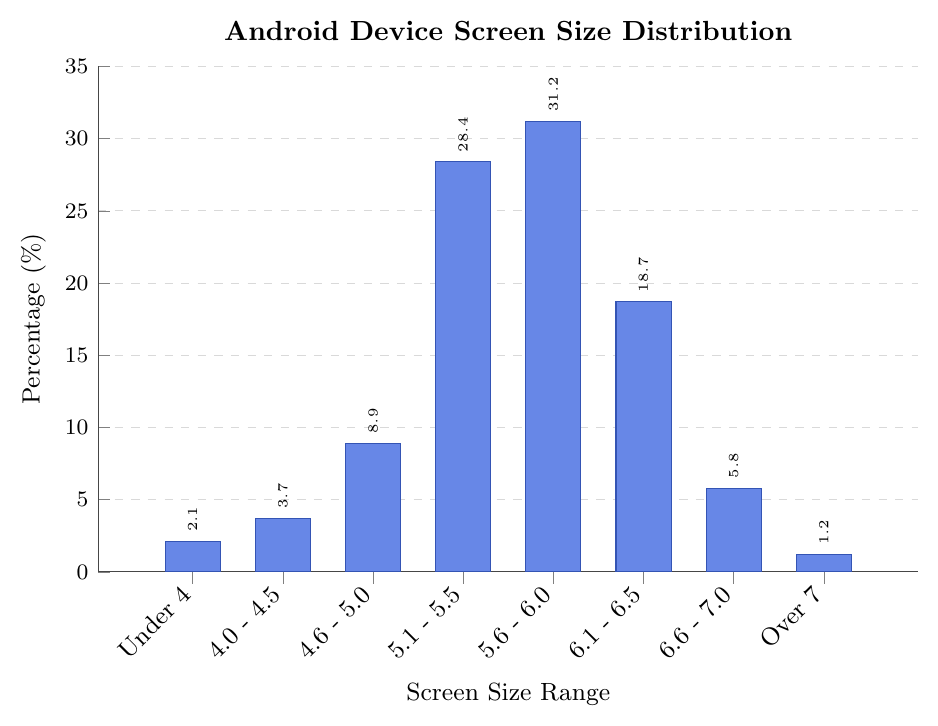What is the most common screen size range among Android devices? The most common screen size range can be identified by looking for the tallest bar in the bar chart. The tallest bar corresponds to "5.6 - 6.0 inches" with a percentage of 31.2%.
Answer: 5.6 - 6.0 inches Which screen size range is the least common? The least common screen size range can be identified by looking for the shortest bar. The shortest bar corresponds to "Over 7 inches" with a percentage of 1.2%.
Answer: Over 7 inches How much more common are devices with screen sizes between 5.1 - 5.5 inches than those under 4 inches? Subtract the percentage of devices under 4 inches from the percentage of devices with screen sizes between 5.1 - 5.5 inches: 28.4% - 2.1% = 26.3%.
Answer: 26.3% What is the combined percentage of devices with screen sizes under 5.0 inches? Sum the percentages of screen size ranges "Under 4 inches", "4.0 - 4.5 inches", and "4.6 - 5.0 inches": 2.1% + 3.7% + 8.9% = 14.7%.
Answer: 14.7% Are there more devices with screen sizes between 6.1 - 6.5 inches or 4.6 - 5.0 inches? Compare the percentages of the two screen size ranges: "6.1 - 6.5 inches" has 18.7% and "4.6 - 5.0 inches" has 8.9%. Since 18.7% is greater than 8.9%, there are more devices with screen sizes between 6.1 - 6.5 inches.
Answer: 6.1 - 6.5 inches What is the average percentage of devices with screen sizes between 4.0 to 7.0 inches? Calculate the average percentage for the ranges "4.0 - 4.5 inches", "4.6 - 5.0 inches", "5.1 - 5.5 inches", "5.6 - 6.0 inches", "6.1 - 6.5 inches", and "6.6 - 7.0 inches". Sum the percentages: 3.7% + 8.9% + 28.4% + 31.2% + 18.7% + 5.8% = 96.7%. Divide by the number of categories (6): 96.7% / 6 ≈ 16.12%.
Answer: 16.12% How many screen size categories have a percentage less than 10%? Count the number of bars with a height less than 10%: "Under 4 inches" (2.1%), "4.0 - 4.5 inches" (3.7%), "4.6 - 5.0 inches" (8.9%), "6.6 - 7.0 inches" (5.8%), and "Over 7 inches" (1.2%) are all below 10%. There are 5 such categories.
Answer: 5 Which screen size category has the second-highest percentage? Rank the bars based on their height. The first highest is "5.6 - 6.0 inches" at 31.2%. The second highest is "5.1 - 5.5 inches" at 28.4%.
Answer: 5.1 - 5.5 inches 